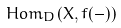<formula> <loc_0><loc_0><loc_500><loc_500>H o m _ { D } ( X , f ( - ) )</formula> 